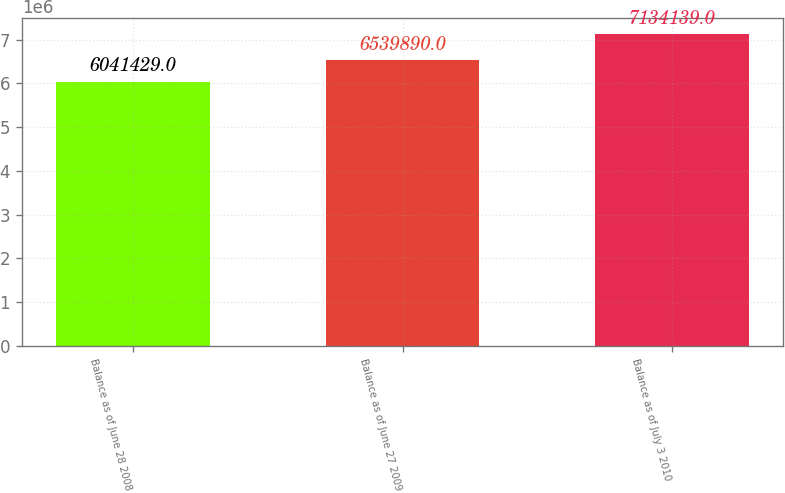Convert chart. <chart><loc_0><loc_0><loc_500><loc_500><bar_chart><fcel>Balance as of June 28 2008<fcel>Balance as of June 27 2009<fcel>Balance as of July 3 2010<nl><fcel>6.04143e+06<fcel>6.53989e+06<fcel>7.13414e+06<nl></chart> 